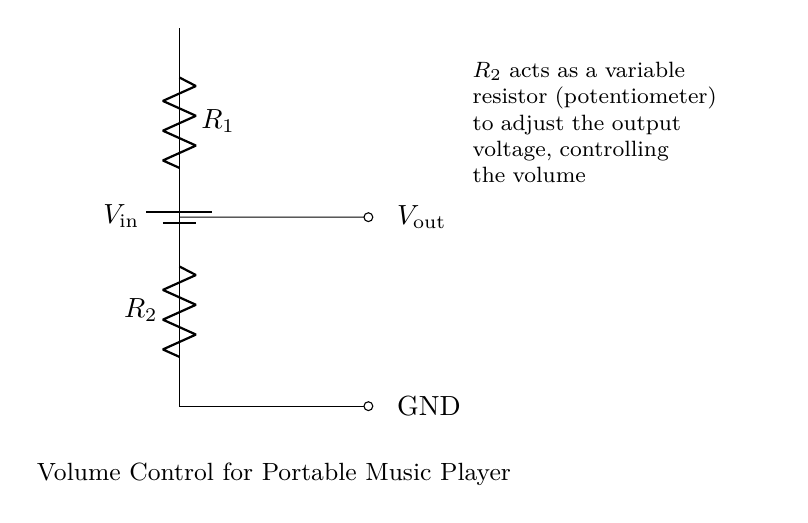What is the input voltage of this circuit? The input voltage symbol is labeled as $V_{\text{in}}$ on the top of the circuit diagram, indicating that it represents the supply voltage applied to the circuit.
Answer: V in What does resistor R2 do? Resistor R2 is labeled as a variable resistor (potentiometer) that adjusts the output voltage to control the volume of the portable music player. This means changing its resistance alters how much voltage is output.
Answer: Volume control What is the output voltage represented by? The output voltage is labeled as $V_{\text{out}}$ in the circuit diagram, indicating its position in relation to the resistors, where it is the voltage across R2 and used for the music player.
Answer: V out How many resistors are there in this circuit? The circuit diagram shows two resistors, R1 and R2, connected in series. This is clear from the way they are represented, with each having its own label in the diagram.
Answer: Two If R2 is increased, what happens to the output voltage? Increasing R2 results in a higher resistance, which leads to a lower output voltage because the voltage divider effect results in a lower proportion of the input voltage appearing across R2.
Answer: Decreases What type of circuit is this? This circuit is a voltage divider used to control the volume in a portable music player, which is specific to this type of circuit as it utilizes resistors to adjust voltage levels.
Answer: Voltage divider 